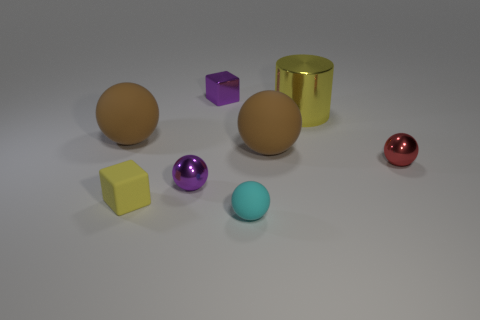Subtract all red metallic balls. How many balls are left? 4 Add 1 tiny cyan rubber balls. How many objects exist? 9 Subtract all purple cylinders. How many brown spheres are left? 2 Subtract all purple balls. How many balls are left? 4 Subtract all blue blocks. Subtract all gray spheres. How many blocks are left? 2 Add 8 small matte blocks. How many small matte blocks are left? 9 Add 1 red shiny blocks. How many red shiny blocks exist? 1 Subtract 0 yellow spheres. How many objects are left? 8 Subtract all cubes. How many objects are left? 6 Subtract all yellow matte blocks. Subtract all red shiny objects. How many objects are left? 6 